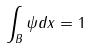<formula> <loc_0><loc_0><loc_500><loc_500>\int _ { B } \psi d x = 1</formula> 